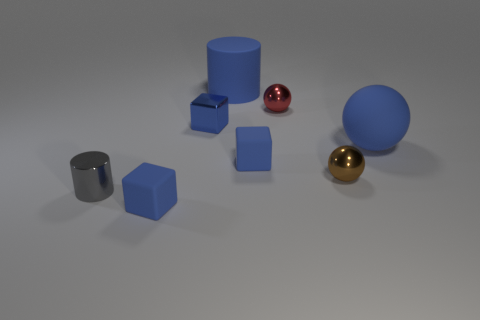What shape is the large object that is the same color as the large rubber cylinder?
Give a very brief answer. Sphere. Are there fewer brown metallic objects that are on the right side of the red metallic thing than large blue things to the right of the tiny brown shiny thing?
Give a very brief answer. No. How many other things are made of the same material as the tiny brown thing?
Your answer should be very brief. 3. Do the big cylinder and the tiny red object have the same material?
Your answer should be very brief. No. How many other objects are the same size as the brown shiny thing?
Make the answer very short. 5. There is a blue matte object in front of the tiny blue rubber thing that is to the right of the matte cylinder; what size is it?
Provide a succinct answer. Small. What is the color of the cylinder that is to the left of the tiny rubber object in front of the small blue rubber thing that is right of the blue shiny block?
Your response must be concise. Gray. What size is the object that is both left of the red metal object and behind the tiny metallic block?
Keep it short and to the point. Large. What number of other objects are there of the same shape as the brown thing?
Make the answer very short. 2. What number of balls are big cyan matte objects or tiny gray shiny things?
Provide a short and direct response. 0. 